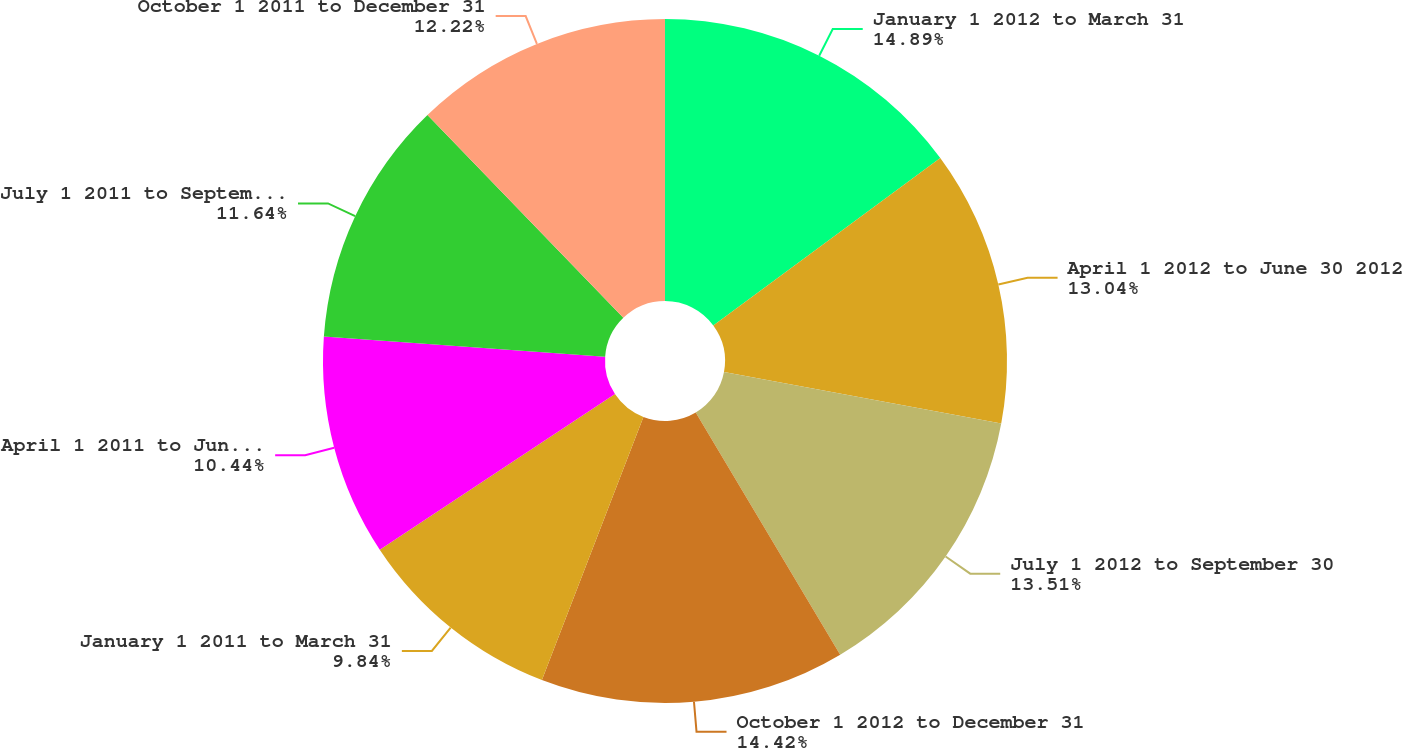Convert chart to OTSL. <chart><loc_0><loc_0><loc_500><loc_500><pie_chart><fcel>January 1 2012 to March 31<fcel>April 1 2012 to June 30 2012<fcel>July 1 2012 to September 30<fcel>October 1 2012 to December 31<fcel>January 1 2011 to March 31<fcel>April 1 2011 to June 30 2011<fcel>July 1 2011 to September 30<fcel>October 1 2011 to December 31<nl><fcel>14.89%<fcel>13.04%<fcel>13.51%<fcel>14.42%<fcel>9.84%<fcel>10.44%<fcel>11.64%<fcel>12.22%<nl></chart> 